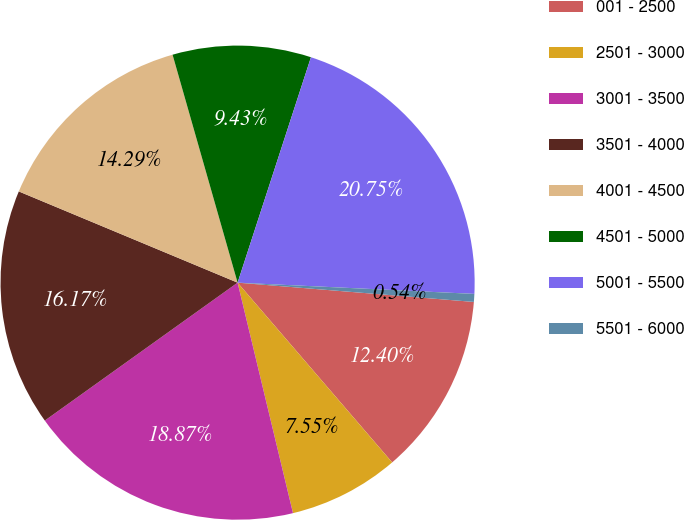Convert chart to OTSL. <chart><loc_0><loc_0><loc_500><loc_500><pie_chart><fcel>001 - 2500<fcel>2501 - 3000<fcel>3001 - 3500<fcel>3501 - 4000<fcel>4001 - 4500<fcel>4501 - 5000<fcel>5001 - 5500<fcel>5501 - 6000<nl><fcel>12.4%<fcel>7.55%<fcel>18.87%<fcel>16.17%<fcel>14.29%<fcel>9.43%<fcel>20.75%<fcel>0.54%<nl></chart> 